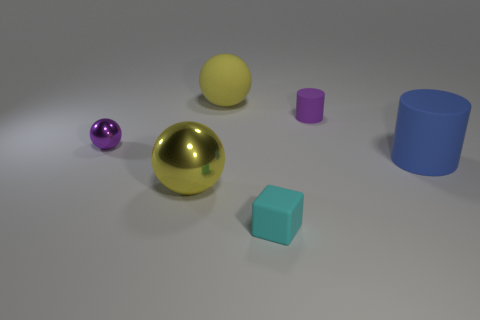Is there anything else that is the same shape as the cyan matte thing?
Keep it short and to the point. No. There is a tiny object that is left of the small cylinder and to the right of the purple ball; what material is it made of?
Keep it short and to the point. Rubber. What number of small purple objects are on the right side of the small purple metallic object?
Give a very brief answer. 1. There is a ball that is the same material as the small purple cylinder; what color is it?
Make the answer very short. Yellow. Is the shape of the yellow rubber thing the same as the small shiny object?
Offer a very short reply. Yes. What number of small objects are to the left of the purple cylinder and behind the big metal object?
Make the answer very short. 1. How many matte objects are yellow things or big blue blocks?
Make the answer very short. 1. What is the size of the purple thing that is right of the big matte object that is behind the purple cylinder?
Offer a terse response. Small. There is another big ball that is the same color as the big matte ball; what is its material?
Make the answer very short. Metal. Are there any rubber blocks that are to the right of the big sphere on the left side of the large rubber thing left of the cyan rubber object?
Make the answer very short. Yes. 